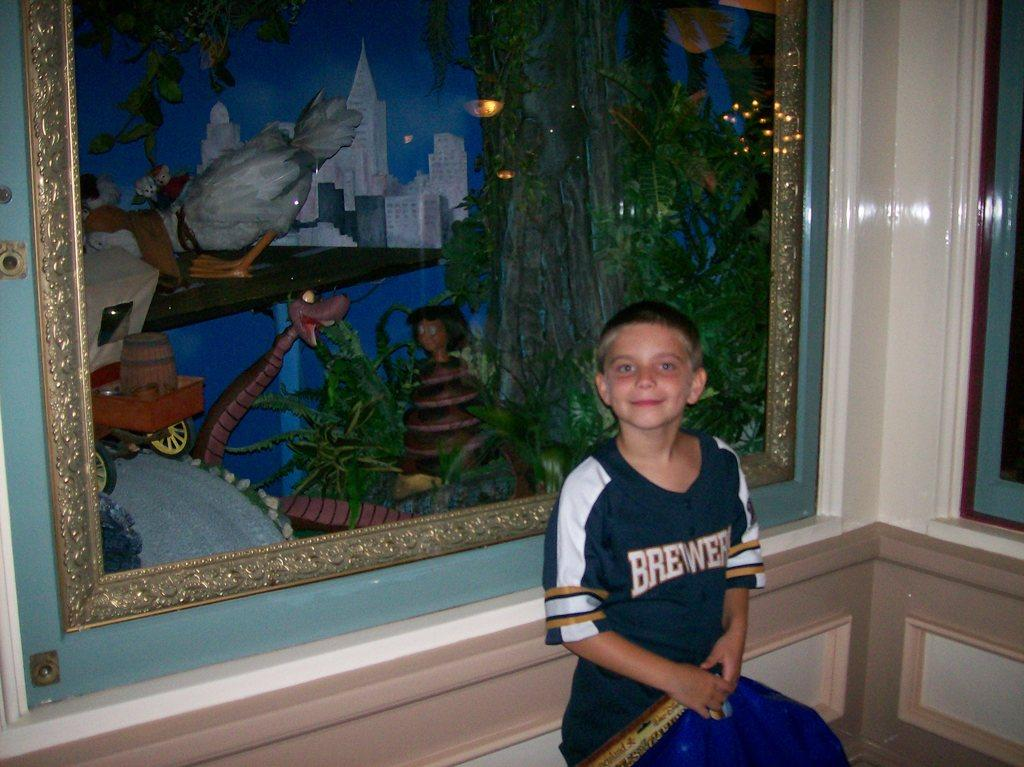<image>
Provide a brief description of the given image. A small boy has a Brewers branded shirt and is posing in front of a painting. 